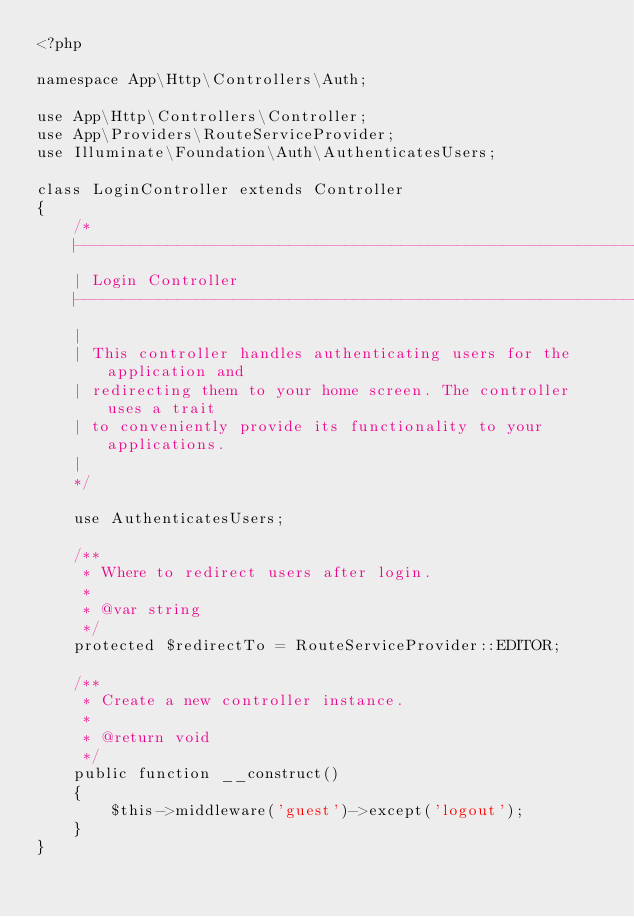<code> <loc_0><loc_0><loc_500><loc_500><_PHP_><?php

namespace App\Http\Controllers\Auth;

use App\Http\Controllers\Controller;
use App\Providers\RouteServiceProvider;
use Illuminate\Foundation\Auth\AuthenticatesUsers;

class LoginController extends Controller
{
    /*
    |--------------------------------------------------------------------------
    | Login Controller
    |--------------------------------------------------------------------------
    |
    | This controller handles authenticating users for the application and
    | redirecting them to your home screen. The controller uses a trait
    | to conveniently provide its functionality to your applications.
    |
    */

    use AuthenticatesUsers;

    /**
     * Where to redirect users after login.
     *
     * @var string
     */
    protected $redirectTo = RouteServiceProvider::EDITOR;

    /**
     * Create a new controller instance.
     *
     * @return void
     */
    public function __construct()
    {
        $this->middleware('guest')->except('logout');
    }
}
</code> 